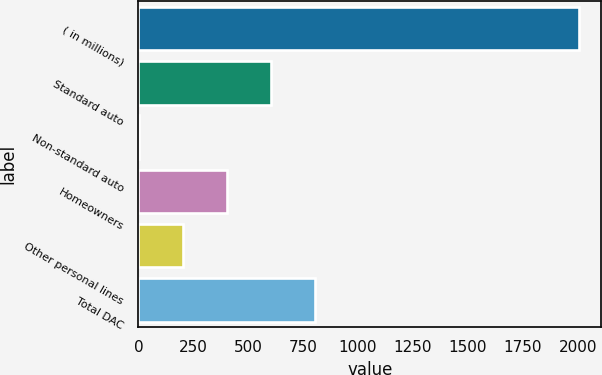Convert chart to OTSL. <chart><loc_0><loc_0><loc_500><loc_500><bar_chart><fcel>( in millions)<fcel>Standard auto<fcel>Non-standard auto<fcel>Homeowners<fcel>Other personal lines<fcel>Total DAC<nl><fcel>2008<fcel>603.1<fcel>1<fcel>402.4<fcel>201.7<fcel>803.8<nl></chart> 